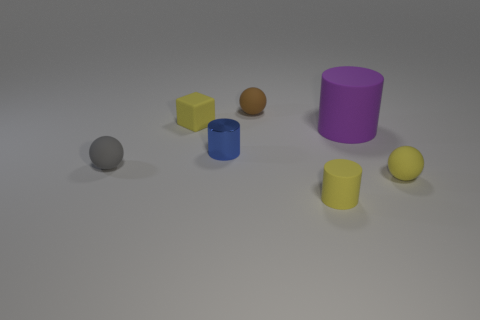Subtract all brown balls. How many balls are left? 2 Add 1 tiny metallic cylinders. How many objects exist? 8 Subtract all yellow cylinders. How many cylinders are left? 2 Subtract 1 spheres. How many spheres are left? 2 Subtract all cubes. How many objects are left? 6 Subtract all big rubber objects. Subtract all blue objects. How many objects are left? 5 Add 5 blue shiny cylinders. How many blue shiny cylinders are left? 6 Add 4 matte balls. How many matte balls exist? 7 Subtract 0 cyan balls. How many objects are left? 7 Subtract all blue cylinders. Subtract all green blocks. How many cylinders are left? 2 